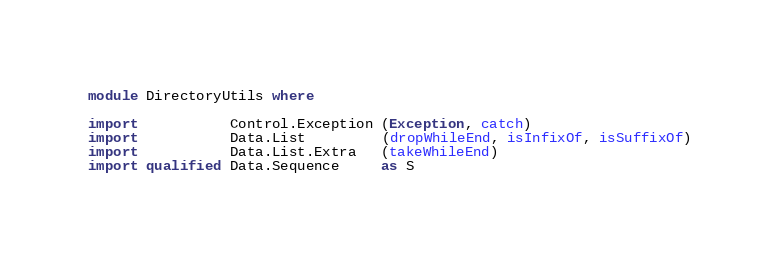<code> <loc_0><loc_0><loc_500><loc_500><_Haskell_>module DirectoryUtils where

import           Control.Exception (Exception, catch)
import           Data.List         (dropWhileEnd, isInfixOf, isSuffixOf)
import           Data.List.Extra   (takeWhileEnd)
import qualified Data.Sequence     as S</code> 